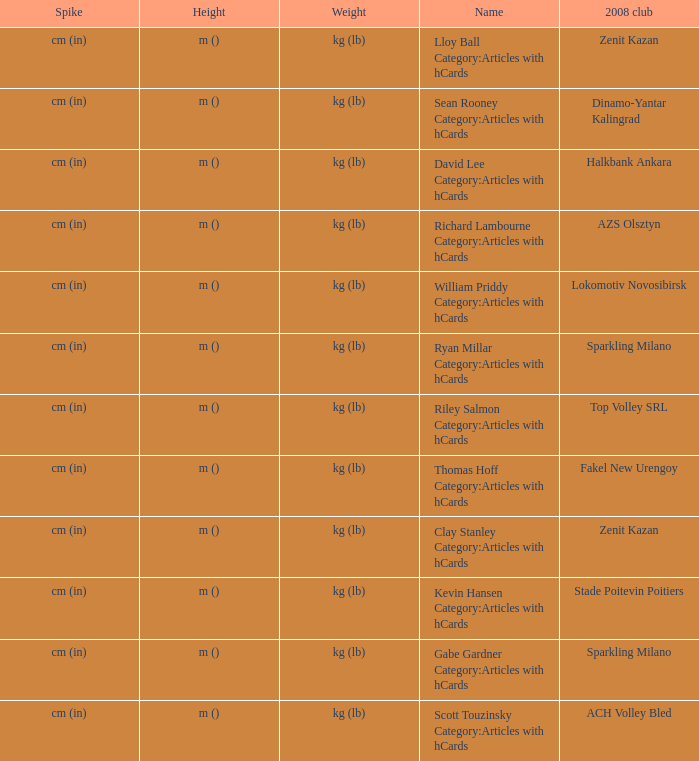What is the name for the 2008 club of Azs olsztyn? Richard Lambourne Category:Articles with hCards. 